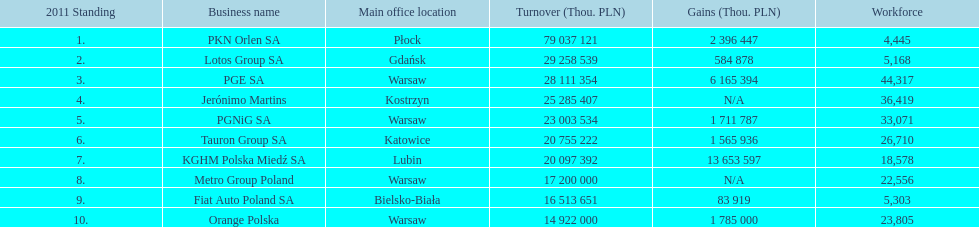Which company had the most employees? PGE SA. 